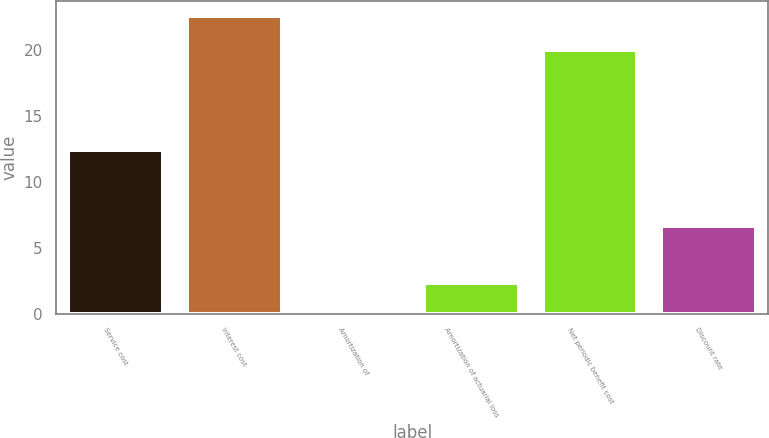Convert chart to OTSL. <chart><loc_0><loc_0><loc_500><loc_500><bar_chart><fcel>Service cost<fcel>Interest cost<fcel>Amortization of<fcel>Amortization of actuarial loss<fcel>Net periodic benefit cost<fcel>Discount rate<nl><fcel>12.4<fcel>22.6<fcel>0.1<fcel>2.35<fcel>20<fcel>6.69<nl></chart> 